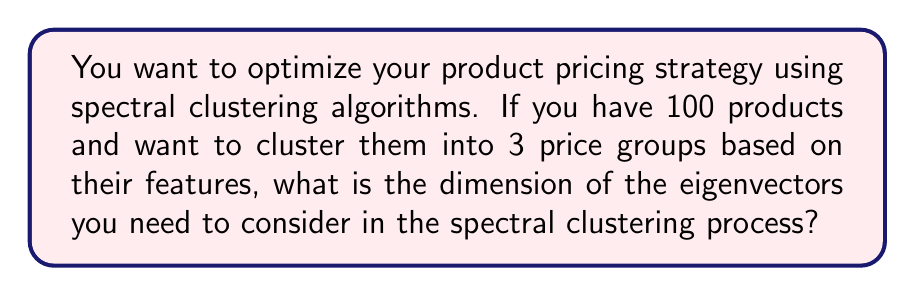Help me with this question. To solve this problem, let's follow these steps:

1. Understand the spectral clustering process:
   Spectral clustering typically involves creating a similarity matrix, computing the Laplacian matrix, and then performing eigendecomposition.

2. Identify the key parameters:
   - Number of products: $n = 100$
   - Number of desired clusters: $k = 3$

3. Recall the spectral clustering algorithm:
   In spectral clustering, we typically use the $k$ smallest eigenvectors of the Laplacian matrix, where $k$ is the number of desired clusters.

4. Determine the dimension of the eigenvectors:
   - Each eigenvector will have a length equal to the number of data points (products in this case).
   - We need $k$ eigenvectors for $k$ clusters.

5. Calculate the final dimension:
   - Each eigenvector has dimension $n = 100$
   - We need $k = 3$ eigenvectors
   - The resulting matrix of eigenvectors will have dimensions $n \times k = 100 \times 3$

Therefore, the dimension of the eigenvectors we need to consider is 3, as we are using the 3 smallest eigenvectors, each of length 100, to perform the clustering into 3 price groups.
Answer: 3 